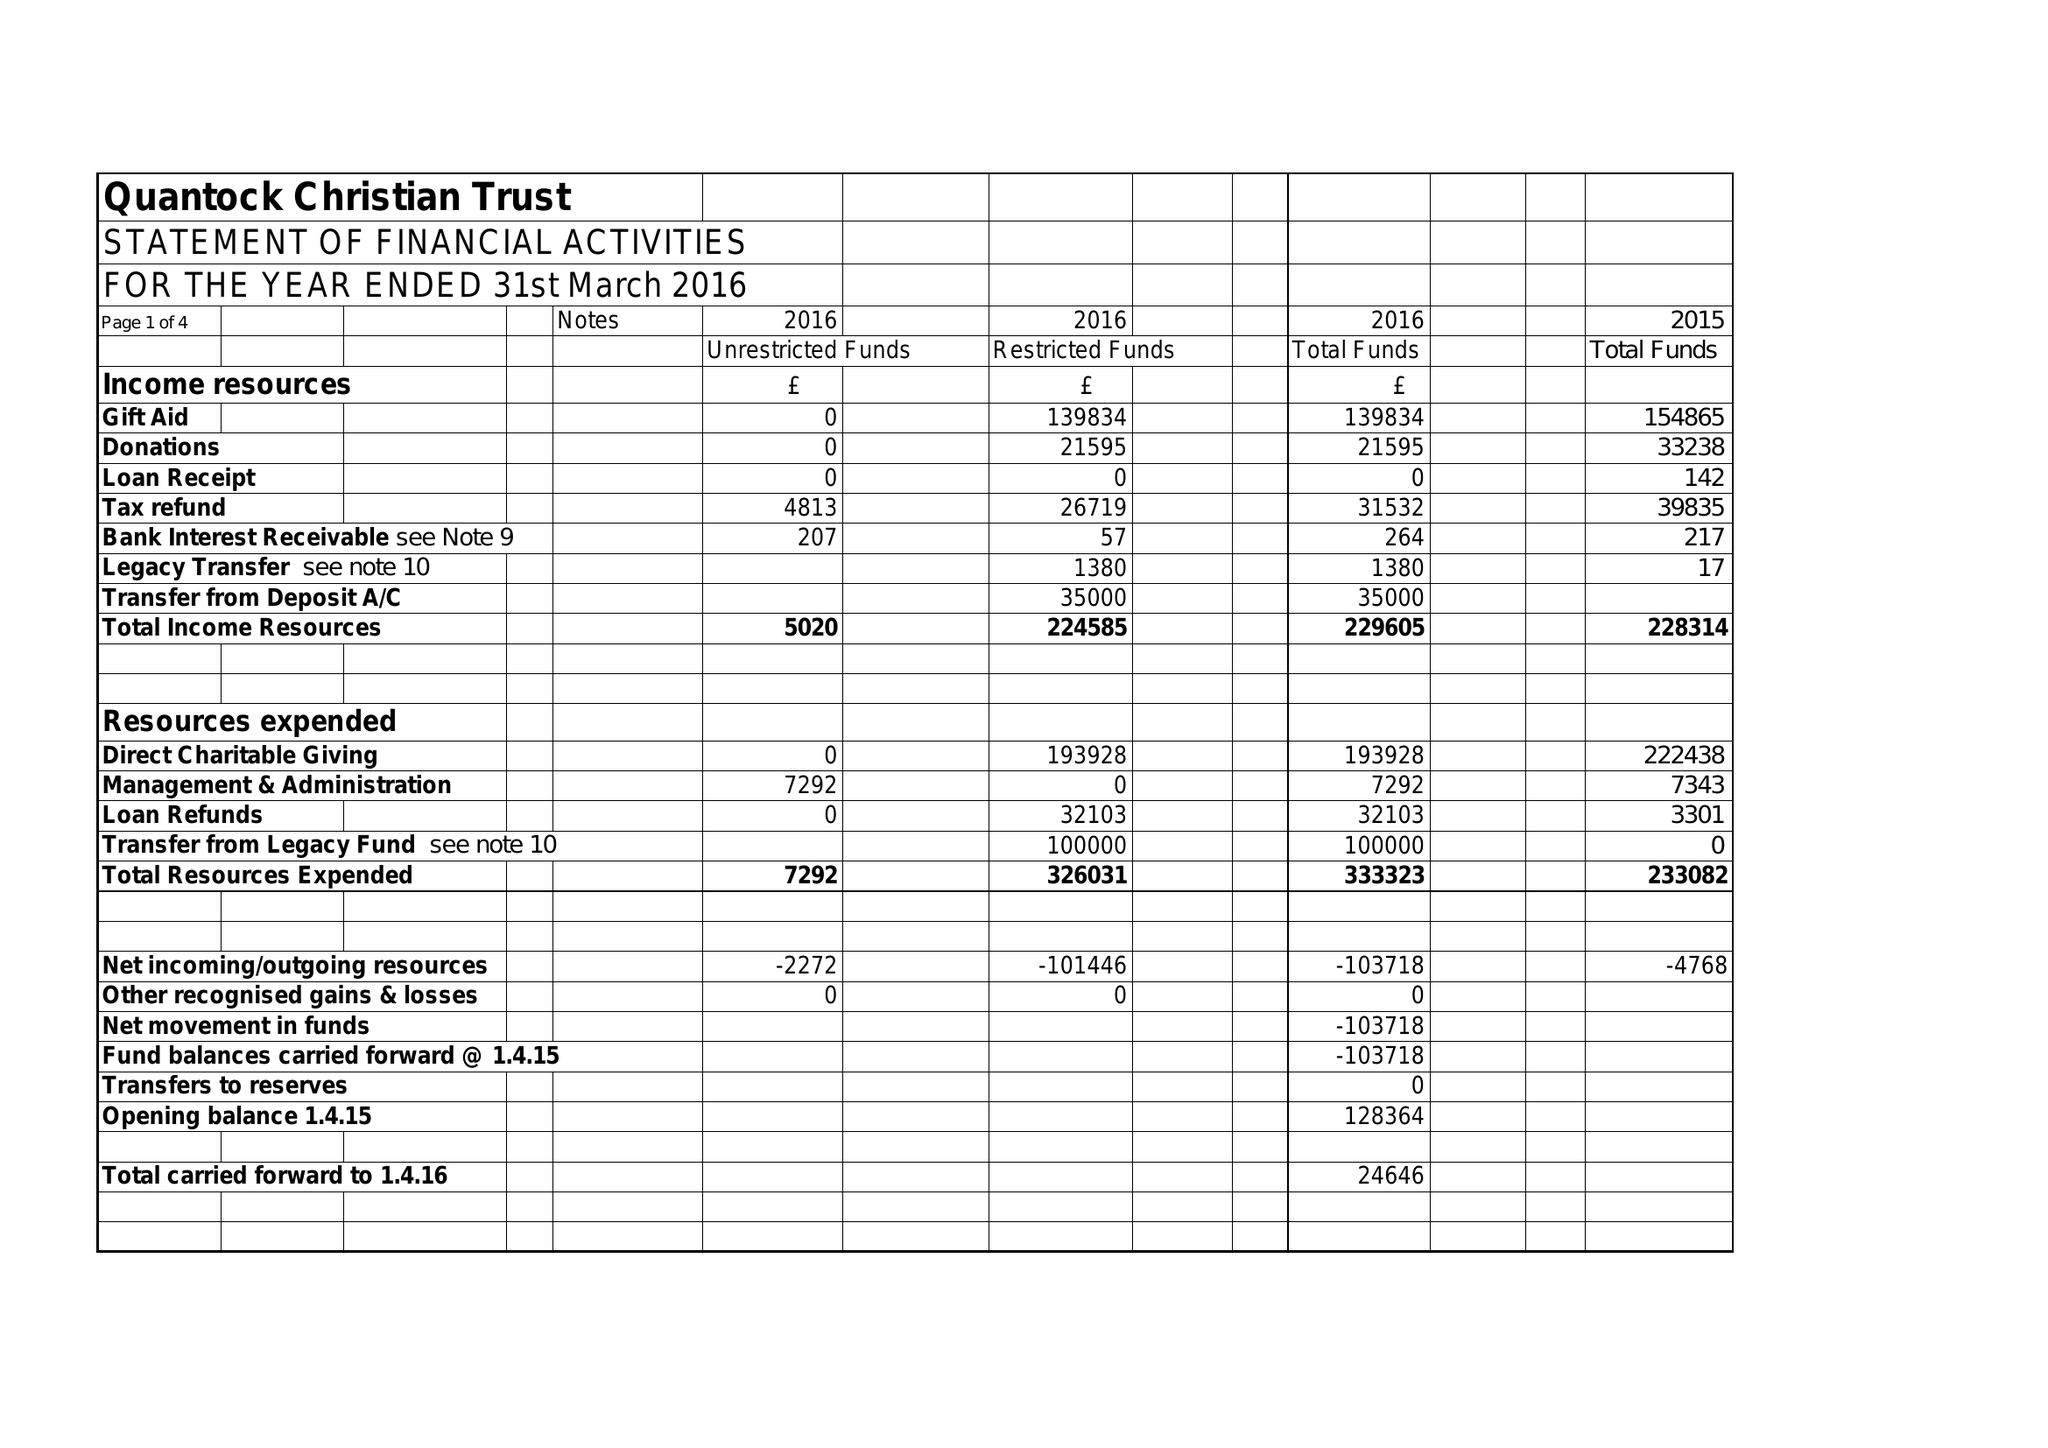What is the value for the address__street_line?
Answer the question using a single word or phrase. 9 ROSARY DRIVE 